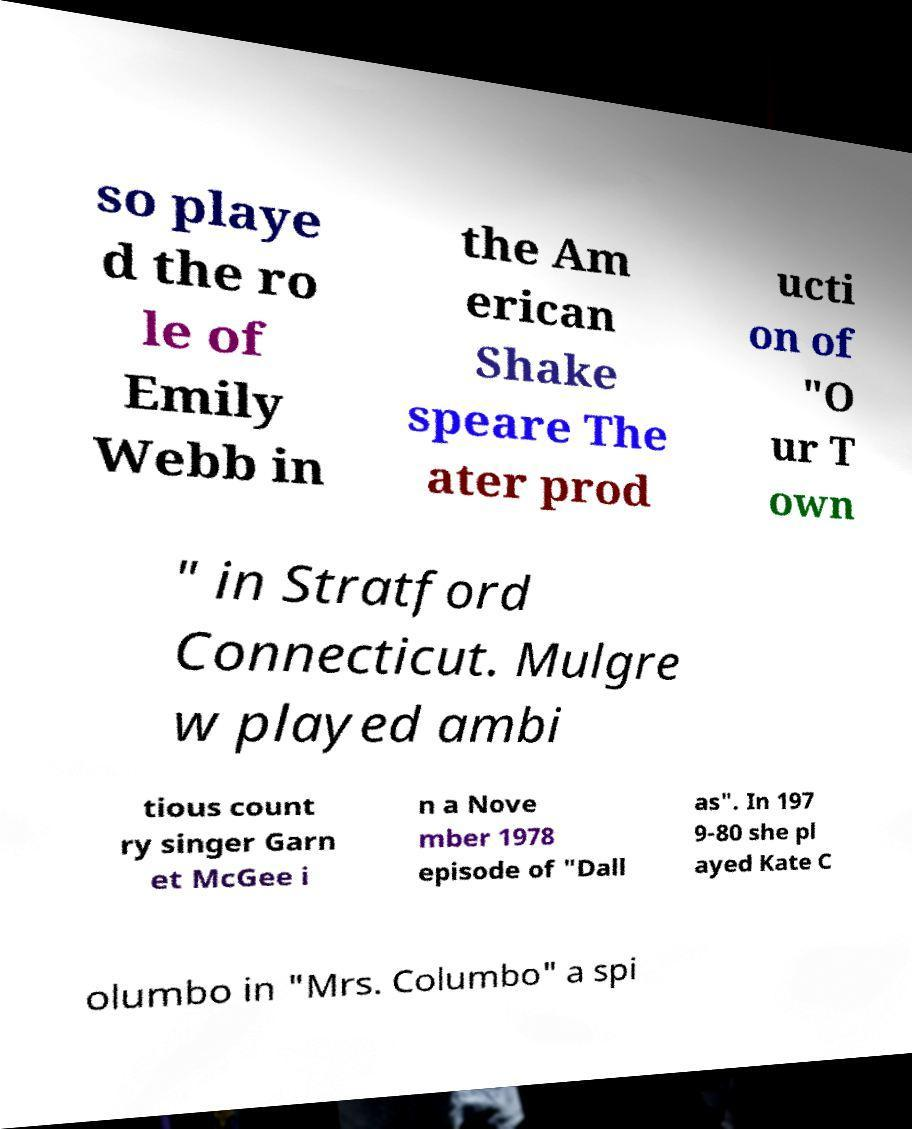Could you assist in decoding the text presented in this image and type it out clearly? so playe d the ro le of Emily Webb in the Am erican Shake speare The ater prod ucti on of "O ur T own " in Stratford Connecticut. Mulgre w played ambi tious count ry singer Garn et McGee i n a Nove mber 1978 episode of "Dall as". In 197 9-80 she pl ayed Kate C olumbo in "Mrs. Columbo" a spi 